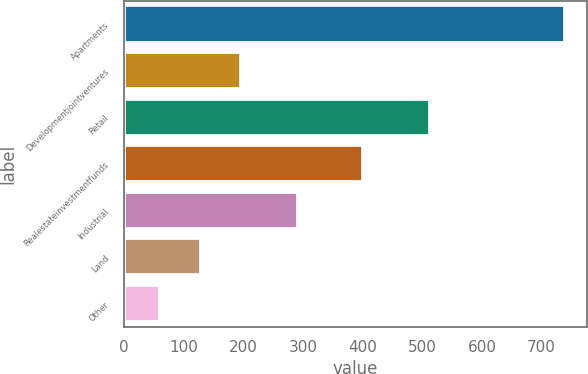Convert chart. <chart><loc_0><loc_0><loc_500><loc_500><bar_chart><fcel>Apartments<fcel>Developmentjointventures<fcel>Retail<fcel>Realestateinvestmentfunds<fcel>Industrial<fcel>Land<fcel>Other<nl><fcel>739<fcel>196.6<fcel>513<fcel>401<fcel>291<fcel>128.8<fcel>61<nl></chart> 